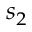<formula> <loc_0><loc_0><loc_500><loc_500>s _ { 2 }</formula> 